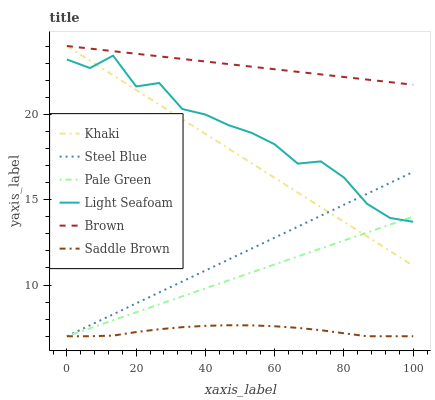Does Saddle Brown have the minimum area under the curve?
Answer yes or no. Yes. Does Brown have the maximum area under the curve?
Answer yes or no. Yes. Does Khaki have the minimum area under the curve?
Answer yes or no. No. Does Khaki have the maximum area under the curve?
Answer yes or no. No. Is Steel Blue the smoothest?
Answer yes or no. Yes. Is Light Seafoam the roughest?
Answer yes or no. Yes. Is Khaki the smoothest?
Answer yes or no. No. Is Khaki the roughest?
Answer yes or no. No. Does Steel Blue have the lowest value?
Answer yes or no. Yes. Does Khaki have the lowest value?
Answer yes or no. No. Does Khaki have the highest value?
Answer yes or no. Yes. Does Steel Blue have the highest value?
Answer yes or no. No. Is Saddle Brown less than Light Seafoam?
Answer yes or no. Yes. Is Khaki greater than Saddle Brown?
Answer yes or no. Yes. Does Pale Green intersect Khaki?
Answer yes or no. Yes. Is Pale Green less than Khaki?
Answer yes or no. No. Is Pale Green greater than Khaki?
Answer yes or no. No. Does Saddle Brown intersect Light Seafoam?
Answer yes or no. No. 